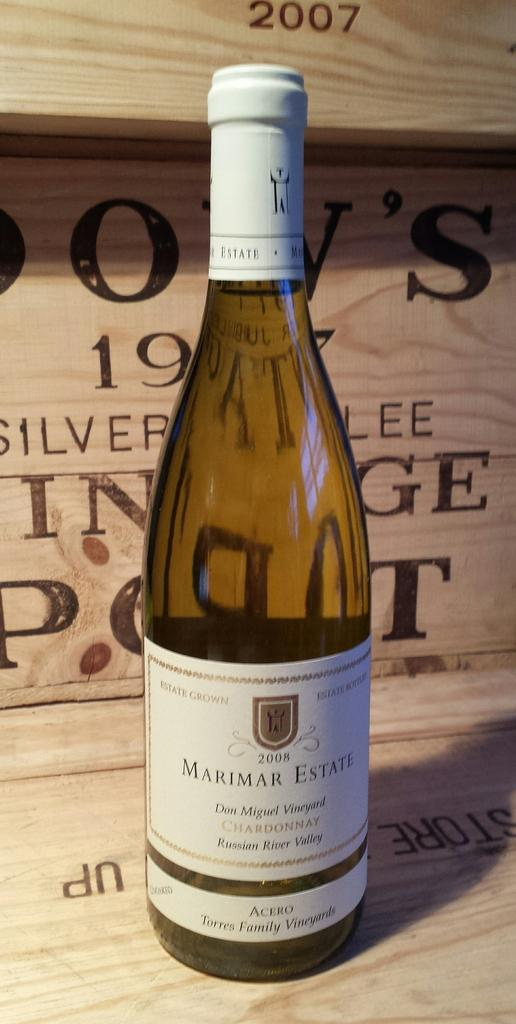What object can be seen in the image? There is a bottle in the image. Can you describe the appearance of the bottle? The bottle is brown and white in color. How does the bottle demonstrate rhythm in the image? The bottle does not demonstrate rhythm in the image, as it is a static object. 